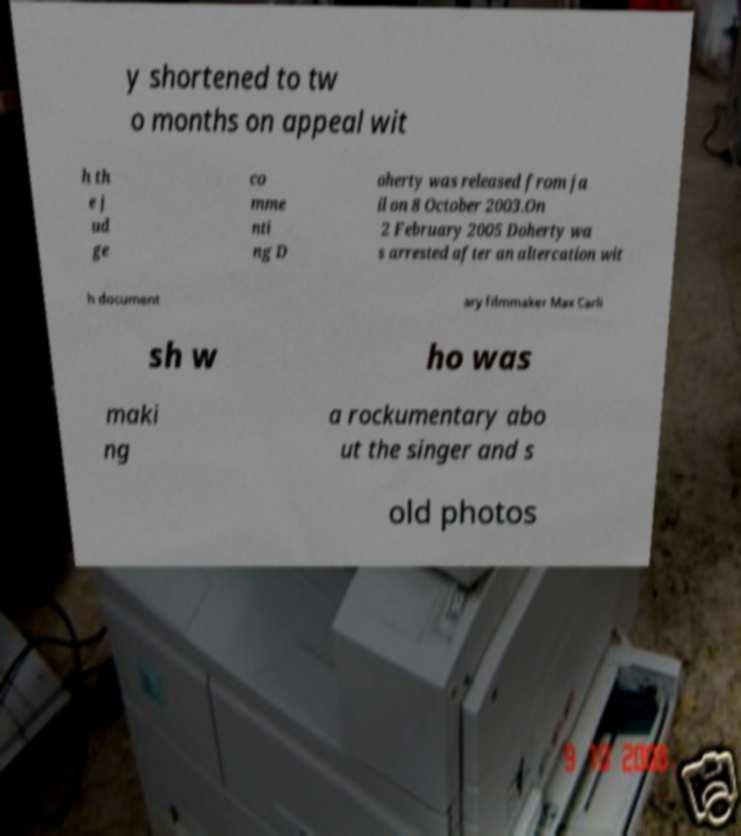Can you read and provide the text displayed in the image?This photo seems to have some interesting text. Can you extract and type it out for me? y shortened to tw o months on appeal wit h th e j ud ge co mme nti ng D oherty was released from ja il on 8 October 2003.On 2 February 2005 Doherty wa s arrested after an altercation wit h document ary filmmaker Max Carli sh w ho was maki ng a rockumentary abo ut the singer and s old photos 